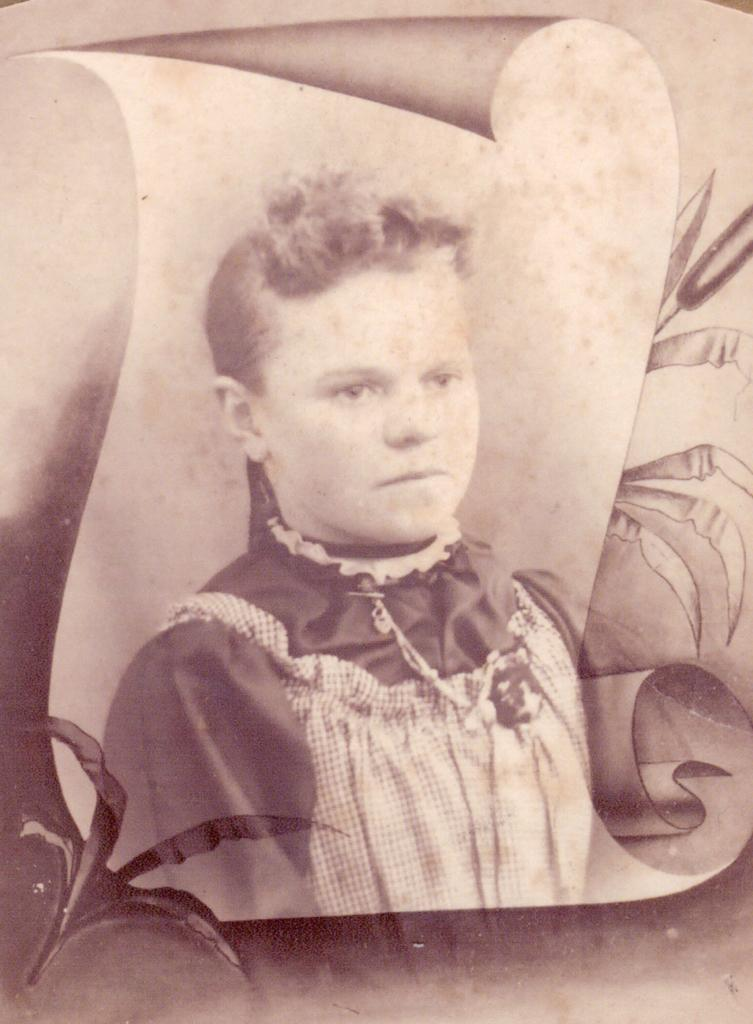What can be observed about the image's appearance? The image is edited. What is the main subject of the image? There is a picture of a person in the image. What occupation does the person in the image have? The provided facts do not mention the person's occupation, so it cannot be determined from the image. 